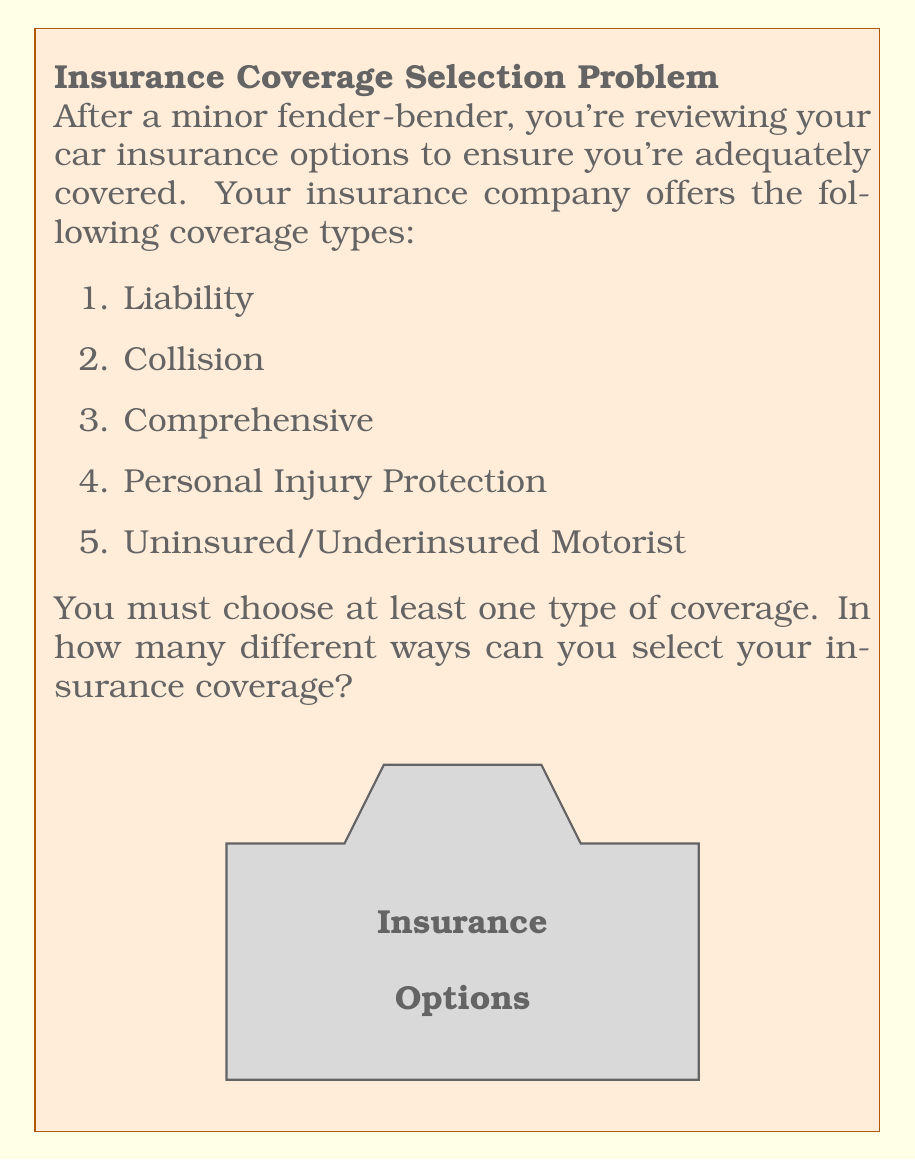Give your solution to this math problem. Let's approach this step-by-step:

1) We have 5 different types of coverage, and we must choose at least one.

2) This is a combination problem where we need to consider all possible ways of selecting 1, 2, 3, 4, or all 5 types of coverage.

3) We can use the formula for combinations:

   $$\binom{n}{k} = \frac{n!}{k!(n-k)!}$$

   Where $n$ is the total number of options (5 in this case) and $k$ is the number we're choosing.

4) Let's calculate for each possibility:

   Choosing 1: $\binom{5}{1} = 5$
   Choosing 2: $\binom{5}{2} = 10$
   Choosing 3: $\binom{5}{3} = 10$
   Choosing 4: $\binom{5}{4} = 5$
   Choosing 5: $\binom{5}{5} = 1$

5) The total number of ways is the sum of all these possibilities:

   $$5 + 10 + 10 + 5 + 1 = 31$$

6) Alternatively, we could have used the formula for the sum of combinations:

   $$\sum_{k=1}^n \binom{n}{k} = 2^n - 1$$

   Where $n$ is the total number of options (5 in this case).

   $$2^5 - 1 = 32 - 1 = 31$$

This gives us the same result.
Answer: 31 